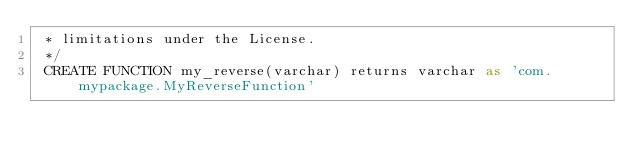<code> <loc_0><loc_0><loc_500><loc_500><_SQL_> * limitations under the License.
 */
 CREATE FUNCTION my_reverse(varchar) returns varchar as 'com.mypackage.MyReverseFunction'
</code> 